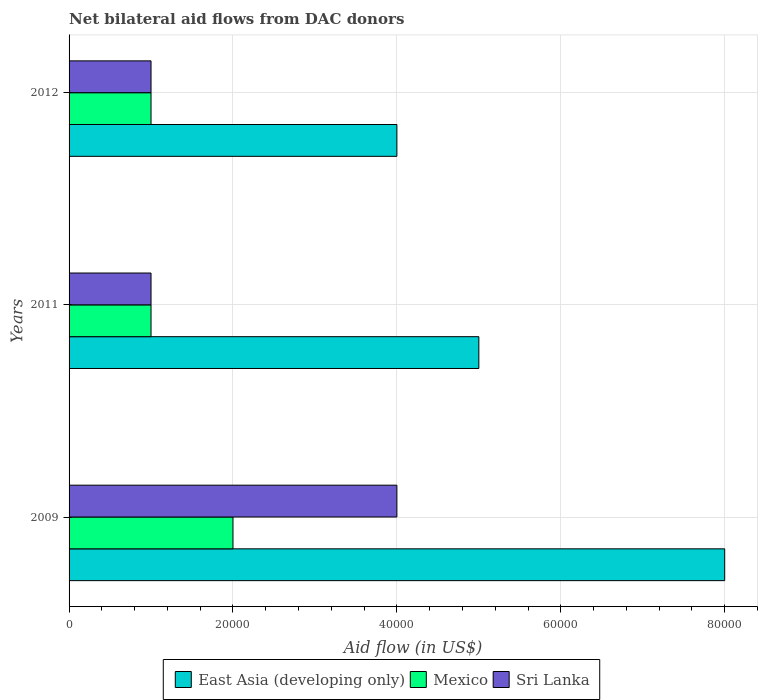How many bars are there on the 2nd tick from the top?
Your response must be concise. 3. What is the net bilateral aid flow in East Asia (developing only) in 2009?
Offer a terse response. 8.00e+04. Across all years, what is the maximum net bilateral aid flow in Sri Lanka?
Ensure brevity in your answer.  4.00e+04. What is the total net bilateral aid flow in East Asia (developing only) in the graph?
Give a very brief answer. 1.70e+05. What is the difference between the net bilateral aid flow in Sri Lanka in 2009 and that in 2011?
Offer a very short reply. 3.00e+04. What is the difference between the net bilateral aid flow in East Asia (developing only) in 2009 and the net bilateral aid flow in Mexico in 2012?
Your response must be concise. 7.00e+04. What is the average net bilateral aid flow in Mexico per year?
Your answer should be very brief. 1.33e+04. In the year 2009, what is the difference between the net bilateral aid flow in East Asia (developing only) and net bilateral aid flow in Mexico?
Ensure brevity in your answer.  6.00e+04. What is the difference between the highest and the lowest net bilateral aid flow in Mexico?
Ensure brevity in your answer.  10000. What does the 1st bar from the top in 2009 represents?
Provide a succinct answer. Sri Lanka. What does the 1st bar from the bottom in 2009 represents?
Keep it short and to the point. East Asia (developing only). What is the difference between two consecutive major ticks on the X-axis?
Offer a terse response. 2.00e+04. Are the values on the major ticks of X-axis written in scientific E-notation?
Your answer should be compact. No. Does the graph contain any zero values?
Provide a short and direct response. No. Where does the legend appear in the graph?
Keep it short and to the point. Bottom center. How many legend labels are there?
Give a very brief answer. 3. How are the legend labels stacked?
Your answer should be compact. Horizontal. What is the title of the graph?
Your answer should be very brief. Net bilateral aid flows from DAC donors. What is the label or title of the X-axis?
Ensure brevity in your answer.  Aid flow (in US$). What is the label or title of the Y-axis?
Provide a succinct answer. Years. What is the Aid flow (in US$) of Mexico in 2009?
Ensure brevity in your answer.  2.00e+04. What is the Aid flow (in US$) in Sri Lanka in 2009?
Your answer should be very brief. 4.00e+04. What is the Aid flow (in US$) in East Asia (developing only) in 2012?
Offer a terse response. 4.00e+04. What is the Aid flow (in US$) in Mexico in 2012?
Offer a terse response. 10000. Across all years, what is the maximum Aid flow (in US$) in Mexico?
Your response must be concise. 2.00e+04. Across all years, what is the minimum Aid flow (in US$) of Mexico?
Keep it short and to the point. 10000. What is the total Aid flow (in US$) of East Asia (developing only) in the graph?
Keep it short and to the point. 1.70e+05. What is the difference between the Aid flow (in US$) of East Asia (developing only) in 2009 and that in 2011?
Your response must be concise. 3.00e+04. What is the difference between the Aid flow (in US$) in Mexico in 2009 and that in 2011?
Your answer should be very brief. 10000. What is the difference between the Aid flow (in US$) in East Asia (developing only) in 2011 and that in 2012?
Provide a succinct answer. 10000. What is the difference between the Aid flow (in US$) in Mexico in 2011 and that in 2012?
Give a very brief answer. 0. What is the difference between the Aid flow (in US$) of East Asia (developing only) in 2009 and the Aid flow (in US$) of Mexico in 2011?
Offer a terse response. 7.00e+04. What is the difference between the Aid flow (in US$) of East Asia (developing only) in 2009 and the Aid flow (in US$) of Sri Lanka in 2011?
Make the answer very short. 7.00e+04. What is the difference between the Aid flow (in US$) in Mexico in 2009 and the Aid flow (in US$) in Sri Lanka in 2011?
Your response must be concise. 10000. What is the difference between the Aid flow (in US$) in East Asia (developing only) in 2009 and the Aid flow (in US$) in Mexico in 2012?
Give a very brief answer. 7.00e+04. What is the difference between the Aid flow (in US$) in Mexico in 2009 and the Aid flow (in US$) in Sri Lanka in 2012?
Ensure brevity in your answer.  10000. What is the difference between the Aid flow (in US$) in East Asia (developing only) in 2011 and the Aid flow (in US$) in Mexico in 2012?
Offer a very short reply. 4.00e+04. What is the average Aid flow (in US$) of East Asia (developing only) per year?
Give a very brief answer. 5.67e+04. What is the average Aid flow (in US$) of Mexico per year?
Make the answer very short. 1.33e+04. In the year 2009, what is the difference between the Aid flow (in US$) in East Asia (developing only) and Aid flow (in US$) in Sri Lanka?
Give a very brief answer. 4.00e+04. In the year 2009, what is the difference between the Aid flow (in US$) in Mexico and Aid flow (in US$) in Sri Lanka?
Offer a very short reply. -2.00e+04. In the year 2011, what is the difference between the Aid flow (in US$) in East Asia (developing only) and Aid flow (in US$) in Sri Lanka?
Give a very brief answer. 4.00e+04. In the year 2011, what is the difference between the Aid flow (in US$) of Mexico and Aid flow (in US$) of Sri Lanka?
Offer a terse response. 0. In the year 2012, what is the difference between the Aid flow (in US$) in East Asia (developing only) and Aid flow (in US$) in Sri Lanka?
Keep it short and to the point. 3.00e+04. In the year 2012, what is the difference between the Aid flow (in US$) in Mexico and Aid flow (in US$) in Sri Lanka?
Ensure brevity in your answer.  0. What is the ratio of the Aid flow (in US$) in Mexico in 2009 to that in 2011?
Provide a succinct answer. 2. What is the ratio of the Aid flow (in US$) of Sri Lanka in 2009 to that in 2011?
Offer a very short reply. 4. What is the ratio of the Aid flow (in US$) of East Asia (developing only) in 2009 to that in 2012?
Your response must be concise. 2. What is the ratio of the Aid flow (in US$) in East Asia (developing only) in 2011 to that in 2012?
Provide a succinct answer. 1.25. What is the difference between the highest and the second highest Aid flow (in US$) of East Asia (developing only)?
Give a very brief answer. 3.00e+04. 